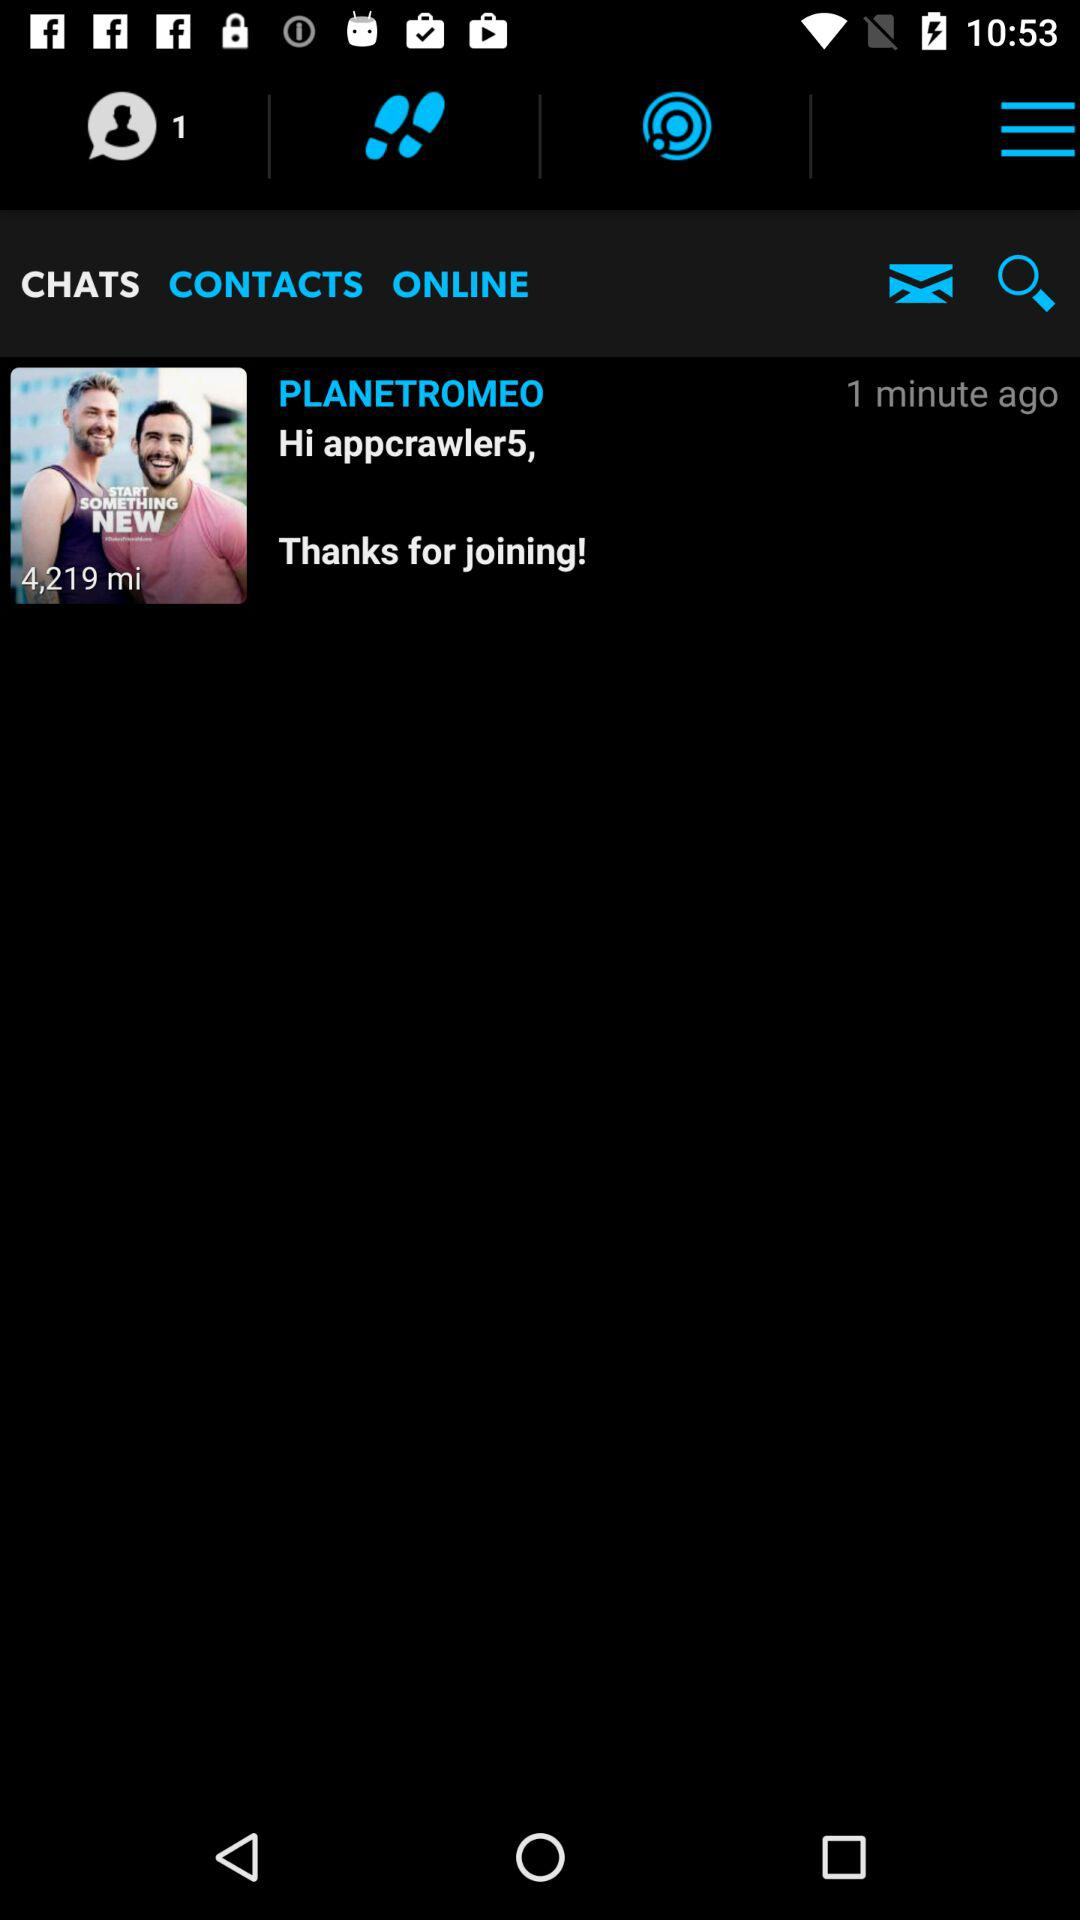How many minutes ago was the message received? The message was received 1 minute ago. 